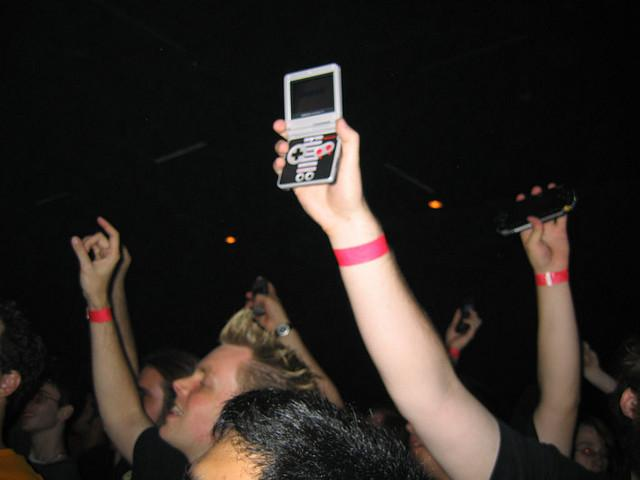The bottom portion of the screen that is furthest to the front looks like what video game controller?

Choices:
A) ps3
B) nes
C) ps4
D) n64 nes 